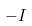Convert formula to latex. <formula><loc_0><loc_0><loc_500><loc_500>- I</formula> 